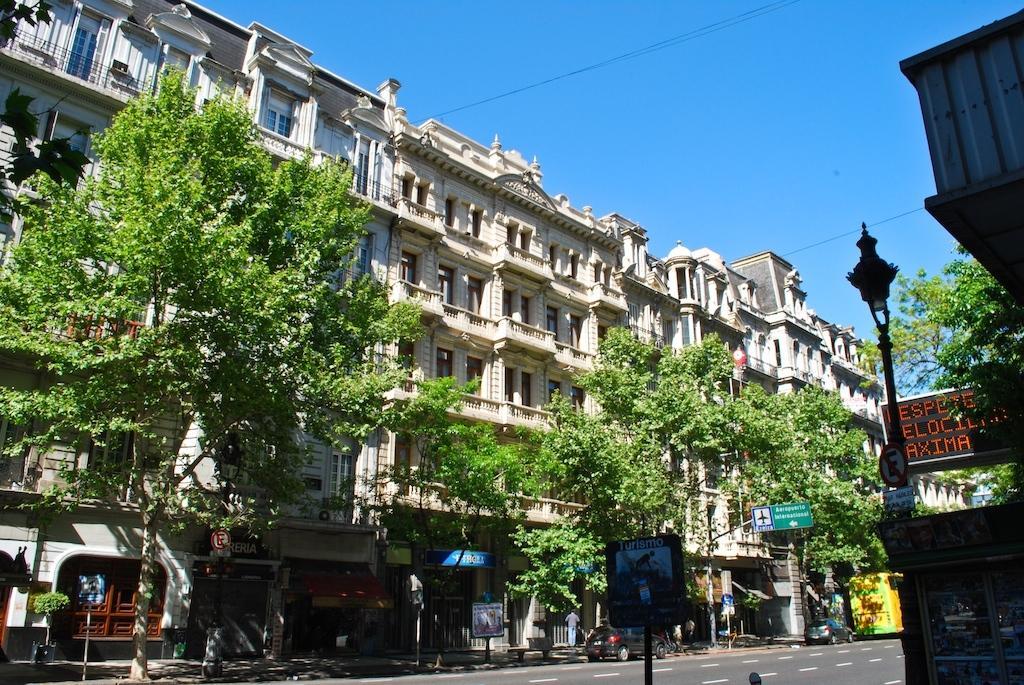How would you summarize this image in a sentence or two? In this picture, we can see a few people, road, a few vehicles, and we can see poles, lights, boards, screens, buildings with windows, trees, and the sky. 